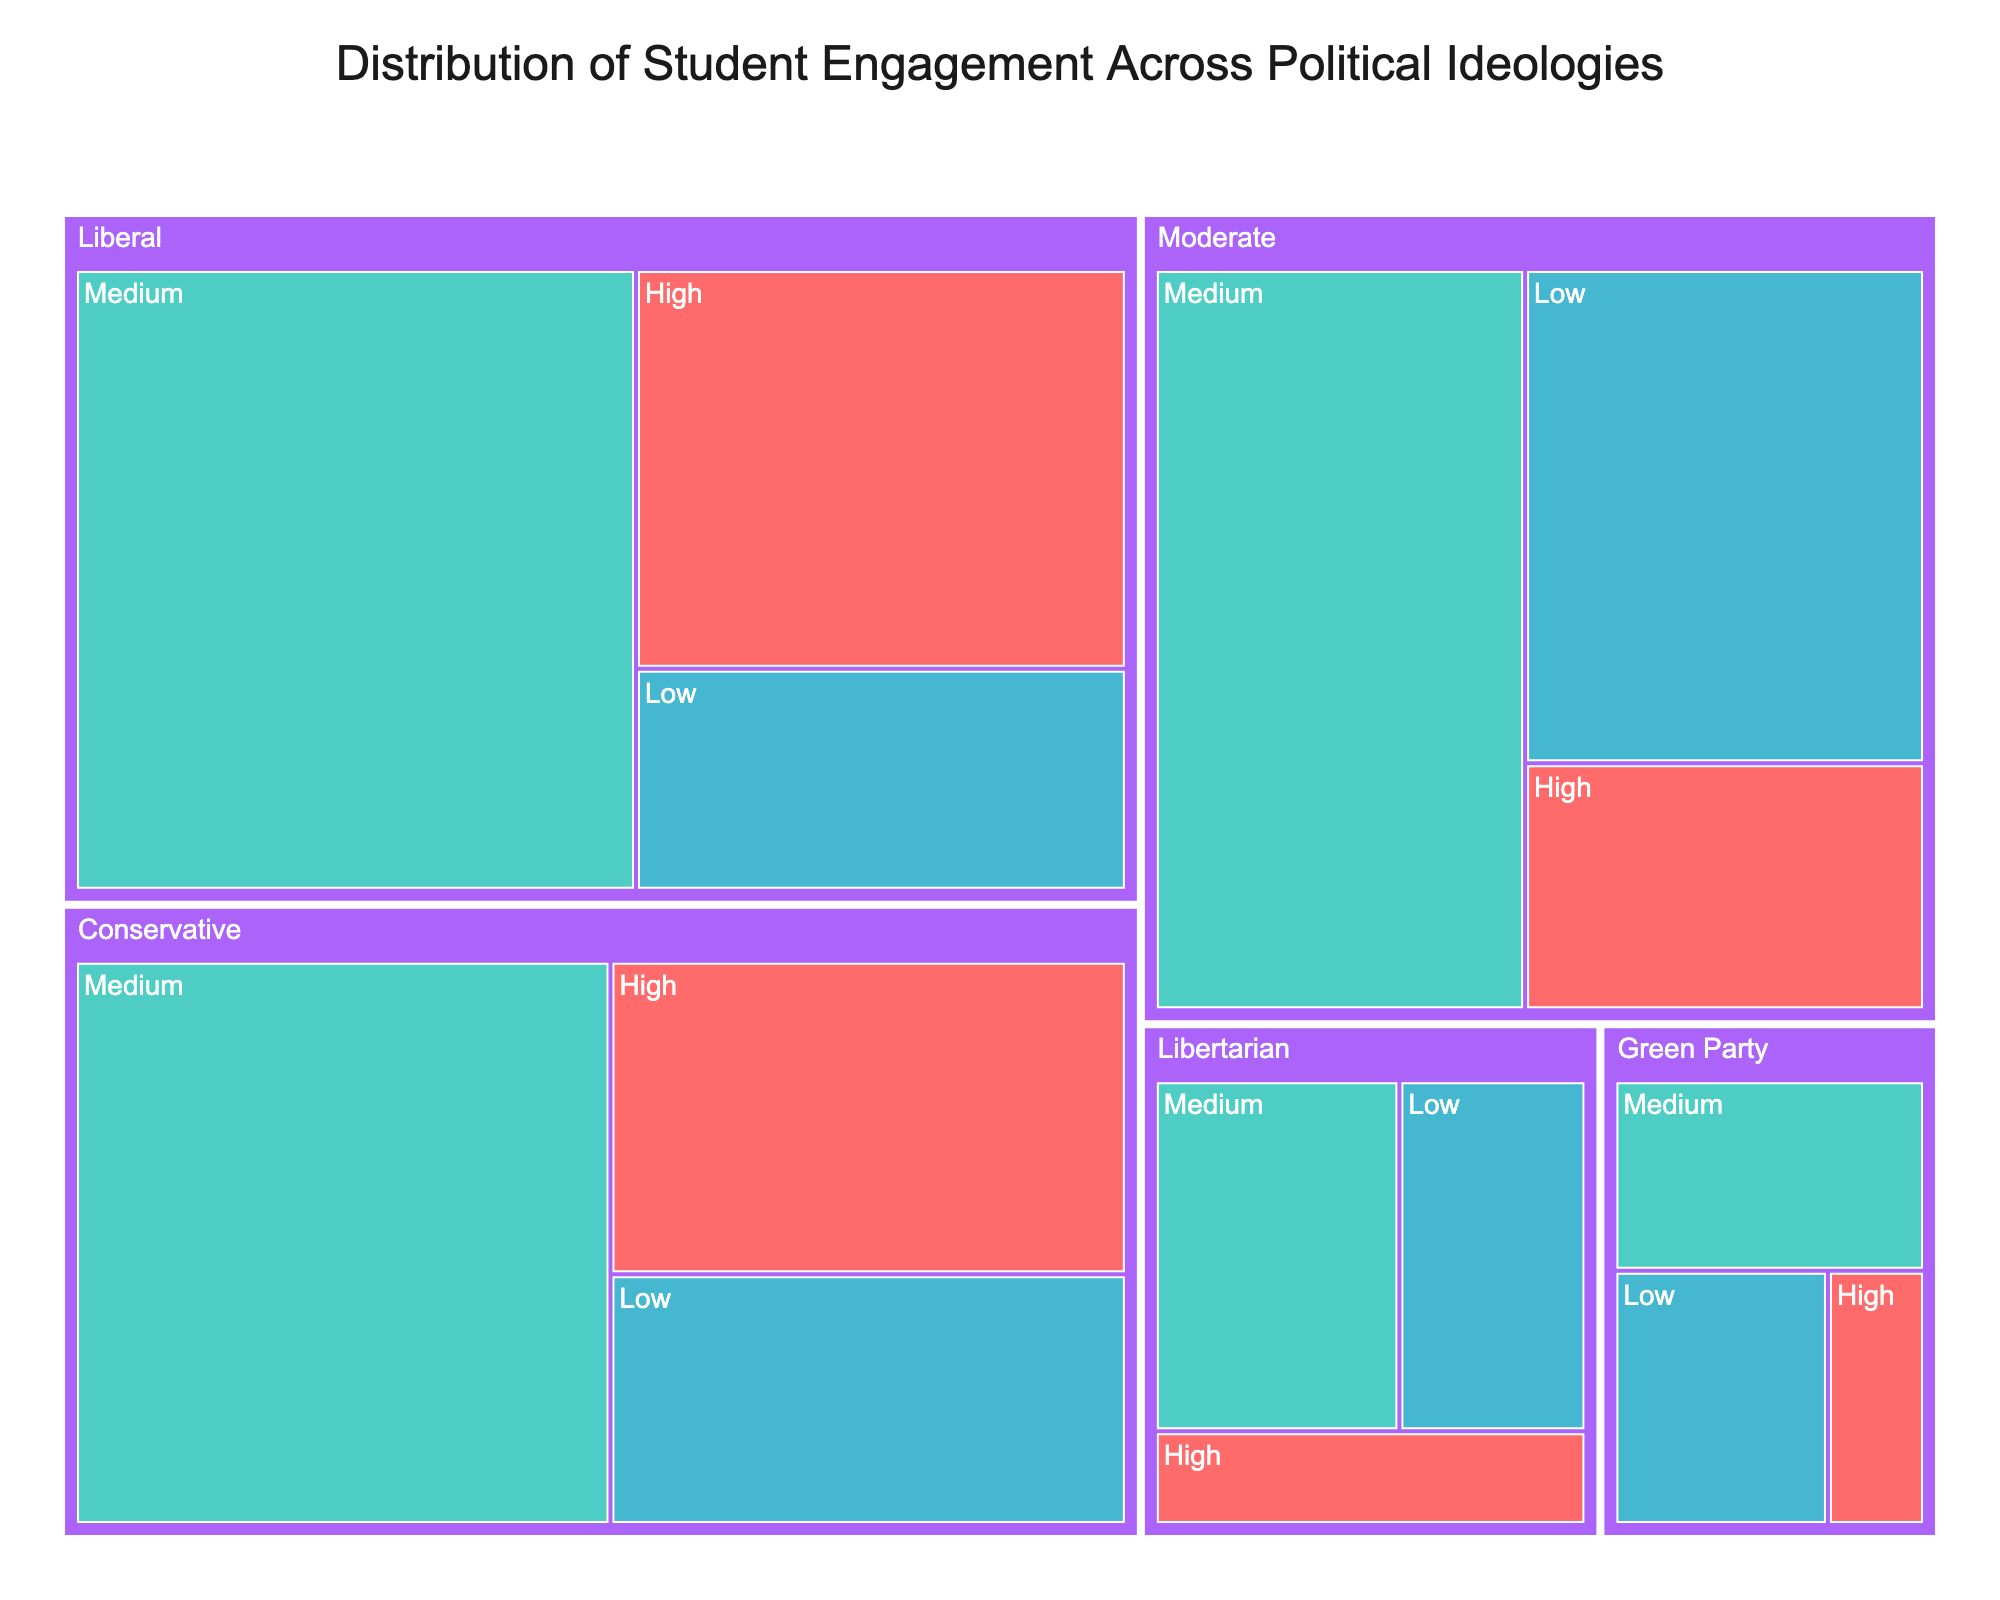What is the title of the treemap? The title is usually placed at the top center of the figure. Look at the top part of the treemap.
Answer: Distribution of Student Engagement Across Political Ideologies Which ideology has the highest number of students with High engagement? To find this, look at the sizes of the rectangles and the label for engagement levels. The largest box under 'High' will represent the ideology with the highest number of highly engaged students.
Answer: Liberal How many students are in the Moderate ideology category? Add the numbers of students with High, Medium, and Low engagement levels within the Moderate ideology category. (90 + 250 + 180)
Answer: 520 Which ideologies have fewer students with Low engagement than the Moderate ideology? Identify the number of students with Low engagement for each ideology and compare it with the Moderate ideology's Low engagement (180).
Answer: Conservative, Liberal, Libertarian, Green Party Is there an ideology with more Medium engaged students than the total number of students in the Libertarian ideology? First, calculate the total number of students in the Libertarian ideology (40 + 85 + 65 = 190). Then compare this with the number of Medium engaged students in each ideology.
Answer: Yes, both Conservative and Liberal ideologies have more Medium engaged students How does the number of students with Low engagement in the Green Party compare with those in the Libertarian ideology? Compare the numbers listed under Low engagement for Green Party (55) and Libertarian (65).
Answer: Libertarian has 10 more students Which ideology has the smallest representation in the High engagement category? Look at the sizes and labels of each rectangle under the High engagement category and identify the smallest one.
Answer: Green Party What's the total number of students in the Liberal ideology? Sum the students in the High, Medium, and Low engagement levels for the Liberal ideology (180 + 320 + 100).
Answer: 600 Which engagement level has the highest representation across all ideologies? Compare the sizes and numbers of all rectangles under High, Medium, and Low engagement levels and identify the largest.
Answer: Medium How many more students are there with Medium engagement in the Liberal ideology compared to the Conservative ideology? Subtract the number of Medium engaged students in the Conservative ideology (280) from the Liberal ideology (320).
Answer: 40 